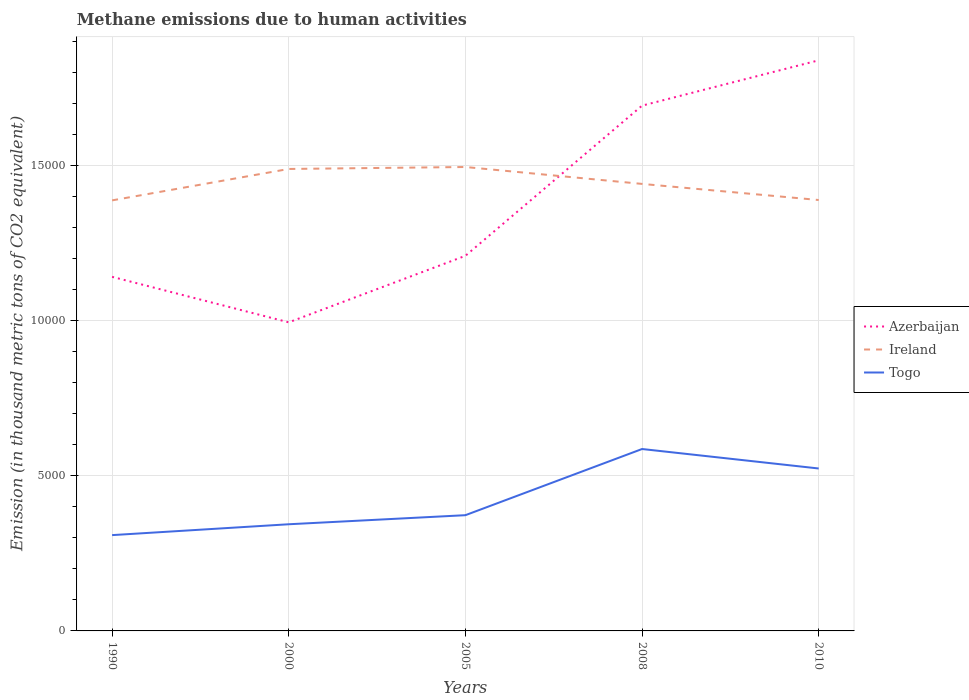Is the number of lines equal to the number of legend labels?
Give a very brief answer. Yes. Across all years, what is the maximum amount of methane emitted in Azerbaijan?
Ensure brevity in your answer.  9950.9. What is the total amount of methane emitted in Ireland in the graph?
Ensure brevity in your answer.  1064.6. What is the difference between the highest and the second highest amount of methane emitted in Azerbaijan?
Your response must be concise. 8449.6. What is the difference between the highest and the lowest amount of methane emitted in Azerbaijan?
Your answer should be compact. 2. How many lines are there?
Give a very brief answer. 3. How many years are there in the graph?
Provide a short and direct response. 5. What is the difference between two consecutive major ticks on the Y-axis?
Ensure brevity in your answer.  5000. How are the legend labels stacked?
Make the answer very short. Vertical. What is the title of the graph?
Provide a short and direct response. Methane emissions due to human activities. Does "Colombia" appear as one of the legend labels in the graph?
Provide a short and direct response. No. What is the label or title of the X-axis?
Ensure brevity in your answer.  Years. What is the label or title of the Y-axis?
Your answer should be compact. Emission (in thousand metric tons of CO2 equivalent). What is the Emission (in thousand metric tons of CO2 equivalent) of Azerbaijan in 1990?
Offer a very short reply. 1.14e+04. What is the Emission (in thousand metric tons of CO2 equivalent) of Ireland in 1990?
Give a very brief answer. 1.39e+04. What is the Emission (in thousand metric tons of CO2 equivalent) in Togo in 1990?
Offer a terse response. 3089.4. What is the Emission (in thousand metric tons of CO2 equivalent) in Azerbaijan in 2000?
Your response must be concise. 9950.9. What is the Emission (in thousand metric tons of CO2 equivalent) in Ireland in 2000?
Make the answer very short. 1.49e+04. What is the Emission (in thousand metric tons of CO2 equivalent) of Togo in 2000?
Give a very brief answer. 3439.6. What is the Emission (in thousand metric tons of CO2 equivalent) in Azerbaijan in 2005?
Give a very brief answer. 1.21e+04. What is the Emission (in thousand metric tons of CO2 equivalent) of Ireland in 2005?
Provide a short and direct response. 1.50e+04. What is the Emission (in thousand metric tons of CO2 equivalent) in Togo in 2005?
Keep it short and to the point. 3731.9. What is the Emission (in thousand metric tons of CO2 equivalent) in Azerbaijan in 2008?
Make the answer very short. 1.69e+04. What is the Emission (in thousand metric tons of CO2 equivalent) of Ireland in 2008?
Your answer should be very brief. 1.44e+04. What is the Emission (in thousand metric tons of CO2 equivalent) of Togo in 2008?
Your answer should be compact. 5866. What is the Emission (in thousand metric tons of CO2 equivalent) of Azerbaijan in 2010?
Offer a very short reply. 1.84e+04. What is the Emission (in thousand metric tons of CO2 equivalent) of Ireland in 2010?
Keep it short and to the point. 1.39e+04. What is the Emission (in thousand metric tons of CO2 equivalent) of Togo in 2010?
Keep it short and to the point. 5237.9. Across all years, what is the maximum Emission (in thousand metric tons of CO2 equivalent) of Azerbaijan?
Your response must be concise. 1.84e+04. Across all years, what is the maximum Emission (in thousand metric tons of CO2 equivalent) in Ireland?
Your answer should be compact. 1.50e+04. Across all years, what is the maximum Emission (in thousand metric tons of CO2 equivalent) of Togo?
Offer a very short reply. 5866. Across all years, what is the minimum Emission (in thousand metric tons of CO2 equivalent) of Azerbaijan?
Make the answer very short. 9950.9. Across all years, what is the minimum Emission (in thousand metric tons of CO2 equivalent) in Ireland?
Your answer should be very brief. 1.39e+04. Across all years, what is the minimum Emission (in thousand metric tons of CO2 equivalent) in Togo?
Your answer should be compact. 3089.4. What is the total Emission (in thousand metric tons of CO2 equivalent) of Azerbaijan in the graph?
Ensure brevity in your answer.  6.88e+04. What is the total Emission (in thousand metric tons of CO2 equivalent) of Ireland in the graph?
Offer a very short reply. 7.21e+04. What is the total Emission (in thousand metric tons of CO2 equivalent) of Togo in the graph?
Your answer should be very brief. 2.14e+04. What is the difference between the Emission (in thousand metric tons of CO2 equivalent) in Azerbaijan in 1990 and that in 2000?
Keep it short and to the point. 1467.3. What is the difference between the Emission (in thousand metric tons of CO2 equivalent) of Ireland in 1990 and that in 2000?
Provide a short and direct response. -1013.1. What is the difference between the Emission (in thousand metric tons of CO2 equivalent) of Togo in 1990 and that in 2000?
Offer a very short reply. -350.2. What is the difference between the Emission (in thousand metric tons of CO2 equivalent) of Azerbaijan in 1990 and that in 2005?
Keep it short and to the point. -678.1. What is the difference between the Emission (in thousand metric tons of CO2 equivalent) of Ireland in 1990 and that in 2005?
Your answer should be very brief. -1076.2. What is the difference between the Emission (in thousand metric tons of CO2 equivalent) of Togo in 1990 and that in 2005?
Provide a short and direct response. -642.5. What is the difference between the Emission (in thousand metric tons of CO2 equivalent) of Azerbaijan in 1990 and that in 2008?
Give a very brief answer. -5520.9. What is the difference between the Emission (in thousand metric tons of CO2 equivalent) in Ireland in 1990 and that in 2008?
Ensure brevity in your answer.  -531.2. What is the difference between the Emission (in thousand metric tons of CO2 equivalent) in Togo in 1990 and that in 2008?
Offer a terse response. -2776.6. What is the difference between the Emission (in thousand metric tons of CO2 equivalent) in Azerbaijan in 1990 and that in 2010?
Ensure brevity in your answer.  -6982.3. What is the difference between the Emission (in thousand metric tons of CO2 equivalent) in Togo in 1990 and that in 2010?
Provide a succinct answer. -2148.5. What is the difference between the Emission (in thousand metric tons of CO2 equivalent) of Azerbaijan in 2000 and that in 2005?
Your answer should be compact. -2145.4. What is the difference between the Emission (in thousand metric tons of CO2 equivalent) in Ireland in 2000 and that in 2005?
Provide a short and direct response. -63.1. What is the difference between the Emission (in thousand metric tons of CO2 equivalent) in Togo in 2000 and that in 2005?
Offer a terse response. -292.3. What is the difference between the Emission (in thousand metric tons of CO2 equivalent) of Azerbaijan in 2000 and that in 2008?
Your answer should be compact. -6988.2. What is the difference between the Emission (in thousand metric tons of CO2 equivalent) of Ireland in 2000 and that in 2008?
Offer a very short reply. 481.9. What is the difference between the Emission (in thousand metric tons of CO2 equivalent) in Togo in 2000 and that in 2008?
Offer a very short reply. -2426.4. What is the difference between the Emission (in thousand metric tons of CO2 equivalent) in Azerbaijan in 2000 and that in 2010?
Give a very brief answer. -8449.6. What is the difference between the Emission (in thousand metric tons of CO2 equivalent) of Ireland in 2000 and that in 2010?
Provide a succinct answer. 1001.5. What is the difference between the Emission (in thousand metric tons of CO2 equivalent) of Togo in 2000 and that in 2010?
Make the answer very short. -1798.3. What is the difference between the Emission (in thousand metric tons of CO2 equivalent) of Azerbaijan in 2005 and that in 2008?
Your answer should be very brief. -4842.8. What is the difference between the Emission (in thousand metric tons of CO2 equivalent) of Ireland in 2005 and that in 2008?
Keep it short and to the point. 545. What is the difference between the Emission (in thousand metric tons of CO2 equivalent) of Togo in 2005 and that in 2008?
Provide a short and direct response. -2134.1. What is the difference between the Emission (in thousand metric tons of CO2 equivalent) of Azerbaijan in 2005 and that in 2010?
Your answer should be compact. -6304.2. What is the difference between the Emission (in thousand metric tons of CO2 equivalent) of Ireland in 2005 and that in 2010?
Provide a short and direct response. 1064.6. What is the difference between the Emission (in thousand metric tons of CO2 equivalent) of Togo in 2005 and that in 2010?
Your response must be concise. -1506. What is the difference between the Emission (in thousand metric tons of CO2 equivalent) of Azerbaijan in 2008 and that in 2010?
Give a very brief answer. -1461.4. What is the difference between the Emission (in thousand metric tons of CO2 equivalent) of Ireland in 2008 and that in 2010?
Keep it short and to the point. 519.6. What is the difference between the Emission (in thousand metric tons of CO2 equivalent) in Togo in 2008 and that in 2010?
Make the answer very short. 628.1. What is the difference between the Emission (in thousand metric tons of CO2 equivalent) of Azerbaijan in 1990 and the Emission (in thousand metric tons of CO2 equivalent) of Ireland in 2000?
Your response must be concise. -3478.8. What is the difference between the Emission (in thousand metric tons of CO2 equivalent) in Azerbaijan in 1990 and the Emission (in thousand metric tons of CO2 equivalent) in Togo in 2000?
Give a very brief answer. 7978.6. What is the difference between the Emission (in thousand metric tons of CO2 equivalent) in Ireland in 1990 and the Emission (in thousand metric tons of CO2 equivalent) in Togo in 2000?
Provide a succinct answer. 1.04e+04. What is the difference between the Emission (in thousand metric tons of CO2 equivalent) in Azerbaijan in 1990 and the Emission (in thousand metric tons of CO2 equivalent) in Ireland in 2005?
Provide a short and direct response. -3541.9. What is the difference between the Emission (in thousand metric tons of CO2 equivalent) of Azerbaijan in 1990 and the Emission (in thousand metric tons of CO2 equivalent) of Togo in 2005?
Your answer should be compact. 7686.3. What is the difference between the Emission (in thousand metric tons of CO2 equivalent) in Ireland in 1990 and the Emission (in thousand metric tons of CO2 equivalent) in Togo in 2005?
Give a very brief answer. 1.02e+04. What is the difference between the Emission (in thousand metric tons of CO2 equivalent) of Azerbaijan in 1990 and the Emission (in thousand metric tons of CO2 equivalent) of Ireland in 2008?
Your answer should be very brief. -2996.9. What is the difference between the Emission (in thousand metric tons of CO2 equivalent) of Azerbaijan in 1990 and the Emission (in thousand metric tons of CO2 equivalent) of Togo in 2008?
Offer a terse response. 5552.2. What is the difference between the Emission (in thousand metric tons of CO2 equivalent) of Ireland in 1990 and the Emission (in thousand metric tons of CO2 equivalent) of Togo in 2008?
Ensure brevity in your answer.  8017.9. What is the difference between the Emission (in thousand metric tons of CO2 equivalent) in Azerbaijan in 1990 and the Emission (in thousand metric tons of CO2 equivalent) in Ireland in 2010?
Your answer should be very brief. -2477.3. What is the difference between the Emission (in thousand metric tons of CO2 equivalent) of Azerbaijan in 1990 and the Emission (in thousand metric tons of CO2 equivalent) of Togo in 2010?
Provide a short and direct response. 6180.3. What is the difference between the Emission (in thousand metric tons of CO2 equivalent) in Ireland in 1990 and the Emission (in thousand metric tons of CO2 equivalent) in Togo in 2010?
Ensure brevity in your answer.  8646. What is the difference between the Emission (in thousand metric tons of CO2 equivalent) of Azerbaijan in 2000 and the Emission (in thousand metric tons of CO2 equivalent) of Ireland in 2005?
Offer a terse response. -5009.2. What is the difference between the Emission (in thousand metric tons of CO2 equivalent) in Azerbaijan in 2000 and the Emission (in thousand metric tons of CO2 equivalent) in Togo in 2005?
Your answer should be very brief. 6219. What is the difference between the Emission (in thousand metric tons of CO2 equivalent) of Ireland in 2000 and the Emission (in thousand metric tons of CO2 equivalent) of Togo in 2005?
Give a very brief answer. 1.12e+04. What is the difference between the Emission (in thousand metric tons of CO2 equivalent) in Azerbaijan in 2000 and the Emission (in thousand metric tons of CO2 equivalent) in Ireland in 2008?
Provide a short and direct response. -4464.2. What is the difference between the Emission (in thousand metric tons of CO2 equivalent) of Azerbaijan in 2000 and the Emission (in thousand metric tons of CO2 equivalent) of Togo in 2008?
Make the answer very short. 4084.9. What is the difference between the Emission (in thousand metric tons of CO2 equivalent) of Ireland in 2000 and the Emission (in thousand metric tons of CO2 equivalent) of Togo in 2008?
Your response must be concise. 9031. What is the difference between the Emission (in thousand metric tons of CO2 equivalent) of Azerbaijan in 2000 and the Emission (in thousand metric tons of CO2 equivalent) of Ireland in 2010?
Offer a very short reply. -3944.6. What is the difference between the Emission (in thousand metric tons of CO2 equivalent) of Azerbaijan in 2000 and the Emission (in thousand metric tons of CO2 equivalent) of Togo in 2010?
Make the answer very short. 4713. What is the difference between the Emission (in thousand metric tons of CO2 equivalent) of Ireland in 2000 and the Emission (in thousand metric tons of CO2 equivalent) of Togo in 2010?
Ensure brevity in your answer.  9659.1. What is the difference between the Emission (in thousand metric tons of CO2 equivalent) in Azerbaijan in 2005 and the Emission (in thousand metric tons of CO2 equivalent) in Ireland in 2008?
Give a very brief answer. -2318.8. What is the difference between the Emission (in thousand metric tons of CO2 equivalent) in Azerbaijan in 2005 and the Emission (in thousand metric tons of CO2 equivalent) in Togo in 2008?
Keep it short and to the point. 6230.3. What is the difference between the Emission (in thousand metric tons of CO2 equivalent) in Ireland in 2005 and the Emission (in thousand metric tons of CO2 equivalent) in Togo in 2008?
Provide a short and direct response. 9094.1. What is the difference between the Emission (in thousand metric tons of CO2 equivalent) in Azerbaijan in 2005 and the Emission (in thousand metric tons of CO2 equivalent) in Ireland in 2010?
Keep it short and to the point. -1799.2. What is the difference between the Emission (in thousand metric tons of CO2 equivalent) of Azerbaijan in 2005 and the Emission (in thousand metric tons of CO2 equivalent) of Togo in 2010?
Offer a terse response. 6858.4. What is the difference between the Emission (in thousand metric tons of CO2 equivalent) of Ireland in 2005 and the Emission (in thousand metric tons of CO2 equivalent) of Togo in 2010?
Your answer should be compact. 9722.2. What is the difference between the Emission (in thousand metric tons of CO2 equivalent) of Azerbaijan in 2008 and the Emission (in thousand metric tons of CO2 equivalent) of Ireland in 2010?
Give a very brief answer. 3043.6. What is the difference between the Emission (in thousand metric tons of CO2 equivalent) of Azerbaijan in 2008 and the Emission (in thousand metric tons of CO2 equivalent) of Togo in 2010?
Offer a terse response. 1.17e+04. What is the difference between the Emission (in thousand metric tons of CO2 equivalent) in Ireland in 2008 and the Emission (in thousand metric tons of CO2 equivalent) in Togo in 2010?
Your response must be concise. 9177.2. What is the average Emission (in thousand metric tons of CO2 equivalent) of Azerbaijan per year?
Give a very brief answer. 1.38e+04. What is the average Emission (in thousand metric tons of CO2 equivalent) in Ireland per year?
Keep it short and to the point. 1.44e+04. What is the average Emission (in thousand metric tons of CO2 equivalent) of Togo per year?
Your response must be concise. 4272.96. In the year 1990, what is the difference between the Emission (in thousand metric tons of CO2 equivalent) of Azerbaijan and Emission (in thousand metric tons of CO2 equivalent) of Ireland?
Offer a very short reply. -2465.7. In the year 1990, what is the difference between the Emission (in thousand metric tons of CO2 equivalent) of Azerbaijan and Emission (in thousand metric tons of CO2 equivalent) of Togo?
Make the answer very short. 8328.8. In the year 1990, what is the difference between the Emission (in thousand metric tons of CO2 equivalent) in Ireland and Emission (in thousand metric tons of CO2 equivalent) in Togo?
Your answer should be very brief. 1.08e+04. In the year 2000, what is the difference between the Emission (in thousand metric tons of CO2 equivalent) of Azerbaijan and Emission (in thousand metric tons of CO2 equivalent) of Ireland?
Keep it short and to the point. -4946.1. In the year 2000, what is the difference between the Emission (in thousand metric tons of CO2 equivalent) in Azerbaijan and Emission (in thousand metric tons of CO2 equivalent) in Togo?
Provide a short and direct response. 6511.3. In the year 2000, what is the difference between the Emission (in thousand metric tons of CO2 equivalent) of Ireland and Emission (in thousand metric tons of CO2 equivalent) of Togo?
Your response must be concise. 1.15e+04. In the year 2005, what is the difference between the Emission (in thousand metric tons of CO2 equivalent) in Azerbaijan and Emission (in thousand metric tons of CO2 equivalent) in Ireland?
Your answer should be compact. -2863.8. In the year 2005, what is the difference between the Emission (in thousand metric tons of CO2 equivalent) in Azerbaijan and Emission (in thousand metric tons of CO2 equivalent) in Togo?
Keep it short and to the point. 8364.4. In the year 2005, what is the difference between the Emission (in thousand metric tons of CO2 equivalent) of Ireland and Emission (in thousand metric tons of CO2 equivalent) of Togo?
Offer a very short reply. 1.12e+04. In the year 2008, what is the difference between the Emission (in thousand metric tons of CO2 equivalent) of Azerbaijan and Emission (in thousand metric tons of CO2 equivalent) of Ireland?
Ensure brevity in your answer.  2524. In the year 2008, what is the difference between the Emission (in thousand metric tons of CO2 equivalent) in Azerbaijan and Emission (in thousand metric tons of CO2 equivalent) in Togo?
Keep it short and to the point. 1.11e+04. In the year 2008, what is the difference between the Emission (in thousand metric tons of CO2 equivalent) of Ireland and Emission (in thousand metric tons of CO2 equivalent) of Togo?
Provide a short and direct response. 8549.1. In the year 2010, what is the difference between the Emission (in thousand metric tons of CO2 equivalent) of Azerbaijan and Emission (in thousand metric tons of CO2 equivalent) of Ireland?
Provide a succinct answer. 4505. In the year 2010, what is the difference between the Emission (in thousand metric tons of CO2 equivalent) in Azerbaijan and Emission (in thousand metric tons of CO2 equivalent) in Togo?
Ensure brevity in your answer.  1.32e+04. In the year 2010, what is the difference between the Emission (in thousand metric tons of CO2 equivalent) in Ireland and Emission (in thousand metric tons of CO2 equivalent) in Togo?
Ensure brevity in your answer.  8657.6. What is the ratio of the Emission (in thousand metric tons of CO2 equivalent) in Azerbaijan in 1990 to that in 2000?
Provide a short and direct response. 1.15. What is the ratio of the Emission (in thousand metric tons of CO2 equivalent) of Ireland in 1990 to that in 2000?
Make the answer very short. 0.93. What is the ratio of the Emission (in thousand metric tons of CO2 equivalent) in Togo in 1990 to that in 2000?
Make the answer very short. 0.9. What is the ratio of the Emission (in thousand metric tons of CO2 equivalent) of Azerbaijan in 1990 to that in 2005?
Keep it short and to the point. 0.94. What is the ratio of the Emission (in thousand metric tons of CO2 equivalent) of Ireland in 1990 to that in 2005?
Provide a short and direct response. 0.93. What is the ratio of the Emission (in thousand metric tons of CO2 equivalent) of Togo in 1990 to that in 2005?
Your answer should be compact. 0.83. What is the ratio of the Emission (in thousand metric tons of CO2 equivalent) of Azerbaijan in 1990 to that in 2008?
Make the answer very short. 0.67. What is the ratio of the Emission (in thousand metric tons of CO2 equivalent) in Ireland in 1990 to that in 2008?
Give a very brief answer. 0.96. What is the ratio of the Emission (in thousand metric tons of CO2 equivalent) in Togo in 1990 to that in 2008?
Ensure brevity in your answer.  0.53. What is the ratio of the Emission (in thousand metric tons of CO2 equivalent) of Azerbaijan in 1990 to that in 2010?
Give a very brief answer. 0.62. What is the ratio of the Emission (in thousand metric tons of CO2 equivalent) of Ireland in 1990 to that in 2010?
Give a very brief answer. 1. What is the ratio of the Emission (in thousand metric tons of CO2 equivalent) in Togo in 1990 to that in 2010?
Keep it short and to the point. 0.59. What is the ratio of the Emission (in thousand metric tons of CO2 equivalent) of Azerbaijan in 2000 to that in 2005?
Make the answer very short. 0.82. What is the ratio of the Emission (in thousand metric tons of CO2 equivalent) in Ireland in 2000 to that in 2005?
Provide a succinct answer. 1. What is the ratio of the Emission (in thousand metric tons of CO2 equivalent) in Togo in 2000 to that in 2005?
Offer a terse response. 0.92. What is the ratio of the Emission (in thousand metric tons of CO2 equivalent) of Azerbaijan in 2000 to that in 2008?
Offer a terse response. 0.59. What is the ratio of the Emission (in thousand metric tons of CO2 equivalent) in Ireland in 2000 to that in 2008?
Make the answer very short. 1.03. What is the ratio of the Emission (in thousand metric tons of CO2 equivalent) of Togo in 2000 to that in 2008?
Offer a terse response. 0.59. What is the ratio of the Emission (in thousand metric tons of CO2 equivalent) in Azerbaijan in 2000 to that in 2010?
Offer a terse response. 0.54. What is the ratio of the Emission (in thousand metric tons of CO2 equivalent) of Ireland in 2000 to that in 2010?
Make the answer very short. 1.07. What is the ratio of the Emission (in thousand metric tons of CO2 equivalent) of Togo in 2000 to that in 2010?
Your answer should be compact. 0.66. What is the ratio of the Emission (in thousand metric tons of CO2 equivalent) in Azerbaijan in 2005 to that in 2008?
Provide a succinct answer. 0.71. What is the ratio of the Emission (in thousand metric tons of CO2 equivalent) in Ireland in 2005 to that in 2008?
Provide a short and direct response. 1.04. What is the ratio of the Emission (in thousand metric tons of CO2 equivalent) in Togo in 2005 to that in 2008?
Keep it short and to the point. 0.64. What is the ratio of the Emission (in thousand metric tons of CO2 equivalent) of Azerbaijan in 2005 to that in 2010?
Your answer should be very brief. 0.66. What is the ratio of the Emission (in thousand metric tons of CO2 equivalent) of Ireland in 2005 to that in 2010?
Keep it short and to the point. 1.08. What is the ratio of the Emission (in thousand metric tons of CO2 equivalent) in Togo in 2005 to that in 2010?
Give a very brief answer. 0.71. What is the ratio of the Emission (in thousand metric tons of CO2 equivalent) in Azerbaijan in 2008 to that in 2010?
Your response must be concise. 0.92. What is the ratio of the Emission (in thousand metric tons of CO2 equivalent) of Ireland in 2008 to that in 2010?
Give a very brief answer. 1.04. What is the ratio of the Emission (in thousand metric tons of CO2 equivalent) in Togo in 2008 to that in 2010?
Provide a short and direct response. 1.12. What is the difference between the highest and the second highest Emission (in thousand metric tons of CO2 equivalent) of Azerbaijan?
Offer a terse response. 1461.4. What is the difference between the highest and the second highest Emission (in thousand metric tons of CO2 equivalent) in Ireland?
Offer a very short reply. 63.1. What is the difference between the highest and the second highest Emission (in thousand metric tons of CO2 equivalent) of Togo?
Your answer should be very brief. 628.1. What is the difference between the highest and the lowest Emission (in thousand metric tons of CO2 equivalent) in Azerbaijan?
Make the answer very short. 8449.6. What is the difference between the highest and the lowest Emission (in thousand metric tons of CO2 equivalent) in Ireland?
Offer a terse response. 1076.2. What is the difference between the highest and the lowest Emission (in thousand metric tons of CO2 equivalent) in Togo?
Your answer should be very brief. 2776.6. 